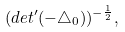<formula> <loc_0><loc_0><loc_500><loc_500>( d e t ^ { \prime } ( - \triangle _ { 0 } ) ) ^ { - \frac { 1 } { 2 } } ,</formula> 